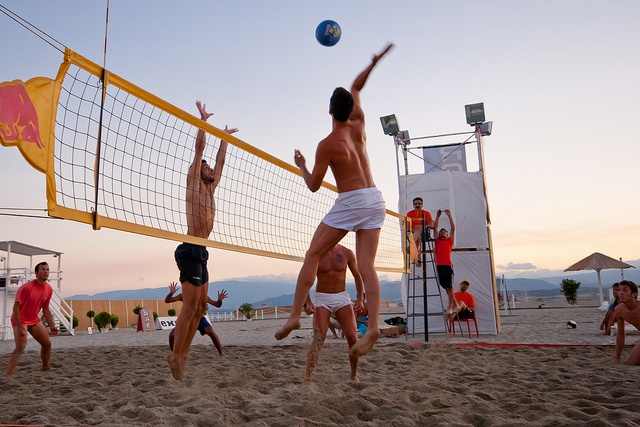Describe the objects in this image and their specific colors. I can see people in darkgray, maroon, lightgray, and gray tones, people in darkgray, maroon, black, and brown tones, people in darkgray, maroon, and gray tones, people in darkgray, maroon, brown, and black tones, and people in darkgray, maroon, black, and gray tones in this image. 